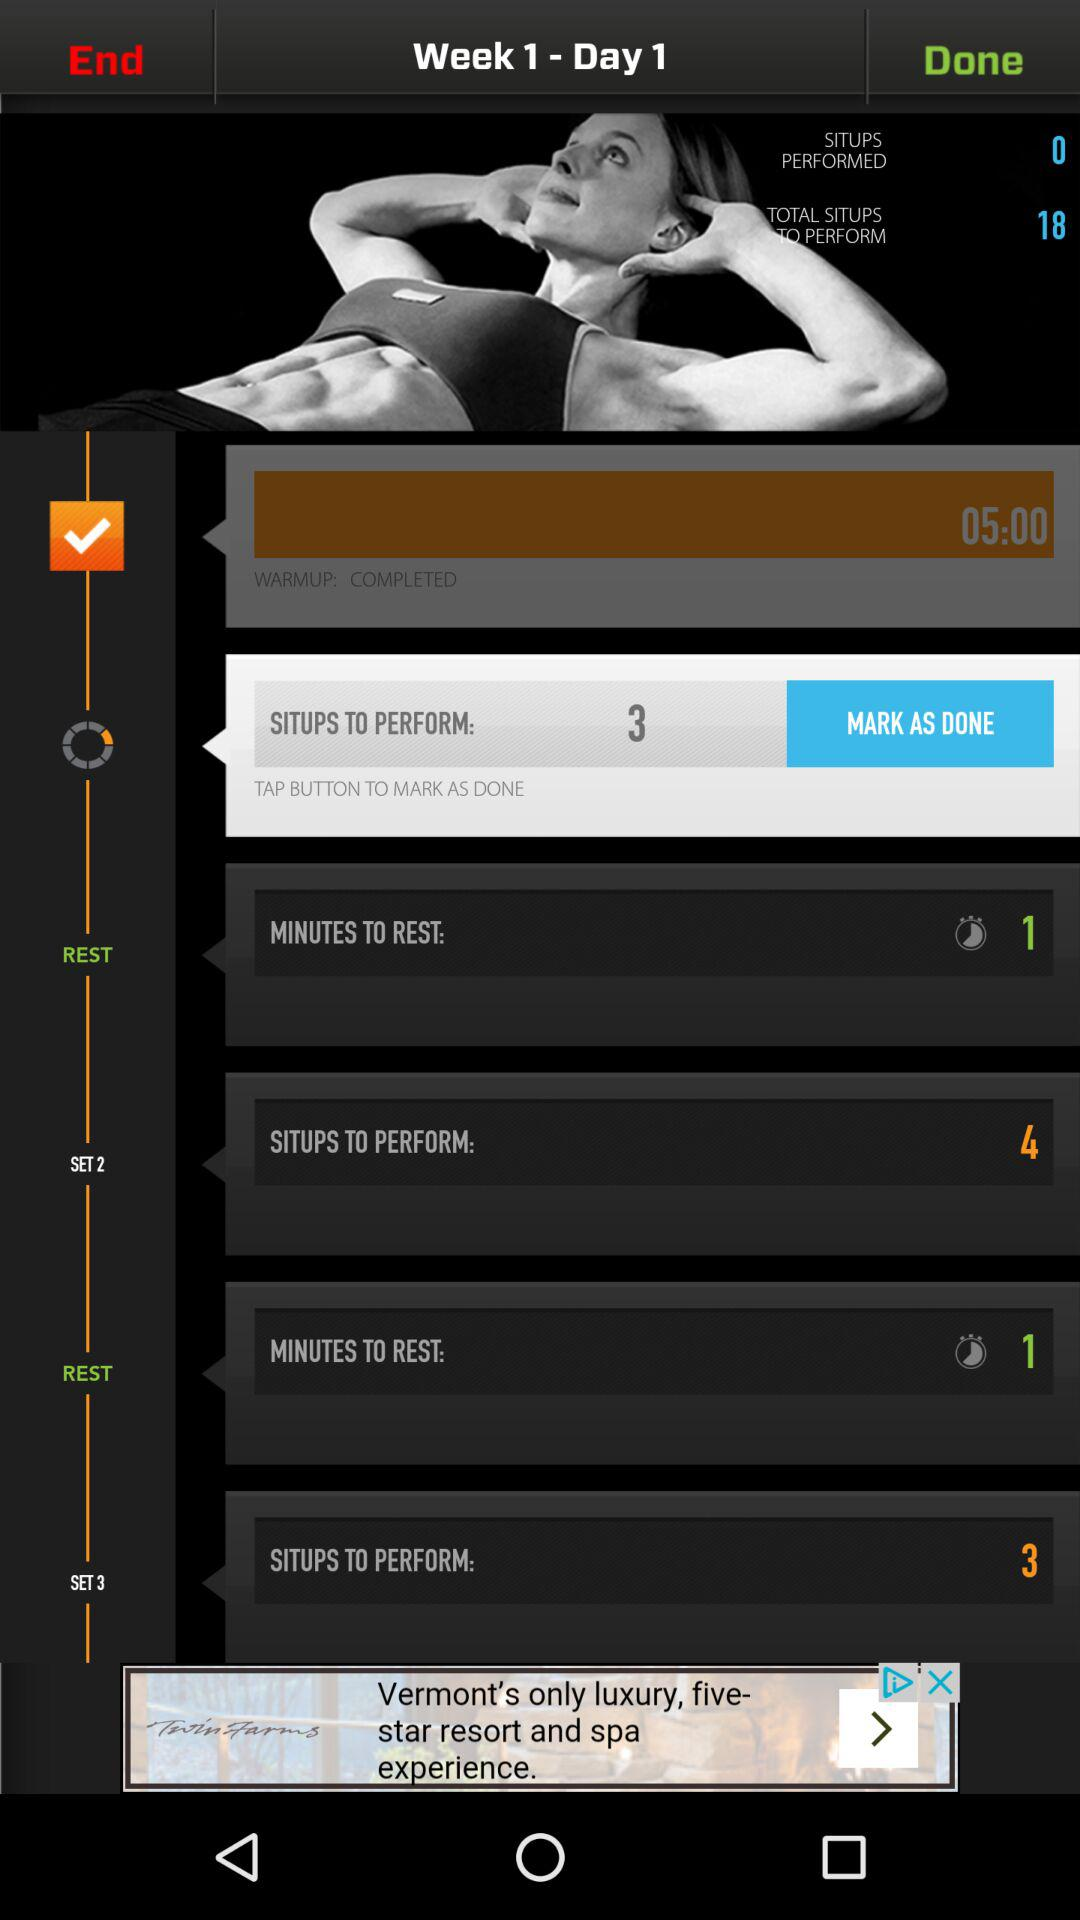How many sets are there in this workout?
Answer the question using a single word or phrase. 3 